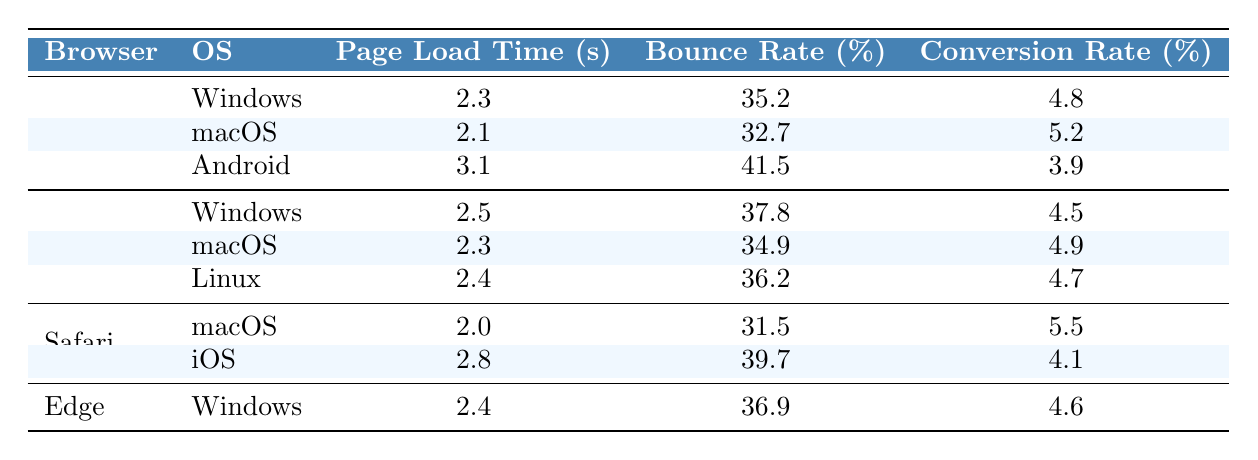What is the page load time for Chrome on macOS? From the table, we can find the row for Chrome under macOS, which shows a page load time of 2.1 seconds.
Answer: 2.1 seconds What is the bounce rate for Safari on iOS? Looking at the table, the bounce rate for Safari under iOS is stated as 39.7%.
Answer: 39.7% Which browser has the highest conversion rate on Windows? Comparing the conversion rates for each browser on Windows, Chrome has 4.8%, Firefox has 4.5%, and Edge has 4.6%. Thus, Chrome has the highest conversion rate on Windows.
Answer: Chrome What is the average page load time across all browsers and operating systems? The page load times are 2.3, 2.1, 3.1, 2.5, 2.3, 2.4, 2.0, 2.8, and 2.4 seconds. Summing these values gives 22.0 seconds and dividing by 9 (the number of entries) results in an average of approximately 2.44 seconds.
Answer: 2.44 seconds Which operating system has the highest bounce rate overall? The bounce rates for each operating system are: Windows (35.2, 37.8, 36.9), macOS (32.7, 34.9, 31.5), Android (41.5), Linux (36.2), and iOS (39.7). The highest is 41.5% for Android.
Answer: Android Is the conversion rate for Firefox lower than for Chrome on Windows? For Windows, the conversion rate for Firefox is 4.5%, while for Chrome, it is 4.8%. Since 4.5% is less than 4.8%, the statement is true.
Answer: Yes What is the difference in the conversion rates of Safari on macOS and iOS? Safari's conversion rates show 5.5% on macOS and 4.1% on iOS. The difference is 5.5% - 4.1% = 1.4%.
Answer: 1.4% Which browser has the highest page load time on Android? Checking the Android metrics, only Chrome is listed with a page load time of 3.1 seconds. So, Chrome has the highest time by default.
Answer: Chrome Is the page load time for Edge better than for Firefox on Windows? For Edge, the page load time is 2.4 seconds, whereas for Firefox, it is 2.5 seconds. Since 2.4 seconds is less than 2.5 seconds, Edge has a better load time.
Answer: Yes How does the bounce rate for Chrome on Windows compare to that for Firefox on macOS? The bounce rate for Chrome on Windows is 35.2% and for Firefox on macOS, it is 34.9%. Since 35.2% is greater than 34.9%, Chrome's rate is higher.
Answer: Higher 